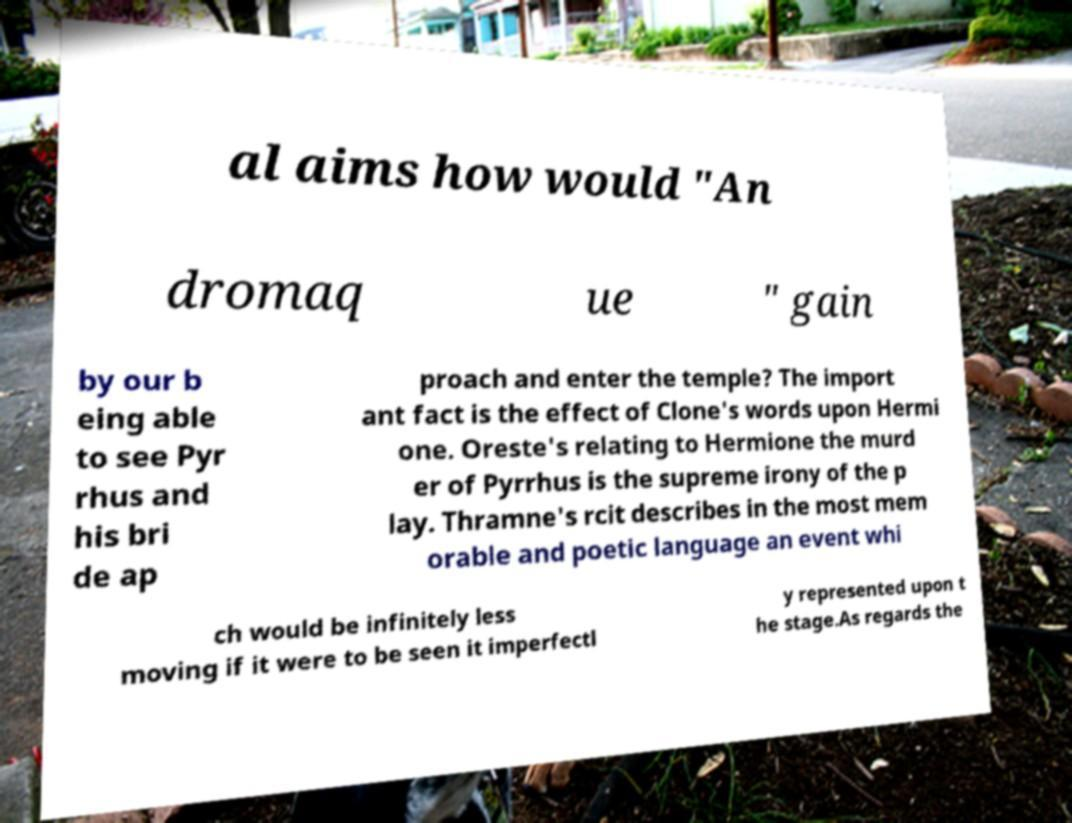Please read and relay the text visible in this image. What does it say? al aims how would "An dromaq ue " gain by our b eing able to see Pyr rhus and his bri de ap proach and enter the temple? The import ant fact is the effect of Clone's words upon Hermi one. Oreste's relating to Hermione the murd er of Pyrrhus is the supreme irony of the p lay. Thramne's rcit describes in the most mem orable and poetic language an event whi ch would be infinitely less moving if it were to be seen it imperfectl y represented upon t he stage.As regards the 